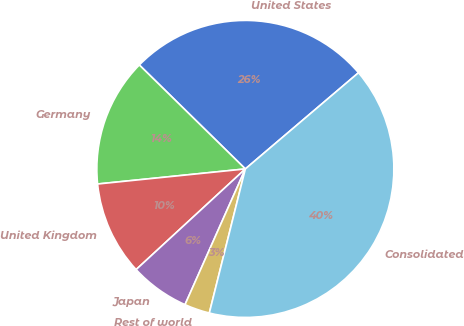Convert chart to OTSL. <chart><loc_0><loc_0><loc_500><loc_500><pie_chart><fcel>United States<fcel>Germany<fcel>United Kingdom<fcel>Japan<fcel>Rest of world<fcel>Consolidated<nl><fcel>26.44%<fcel>13.96%<fcel>10.23%<fcel>6.49%<fcel>2.76%<fcel>40.11%<nl></chart> 